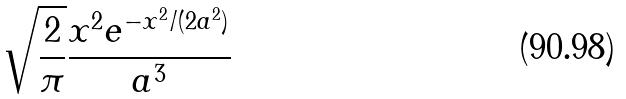Convert formula to latex. <formula><loc_0><loc_0><loc_500><loc_500>\sqrt { \frac { 2 } { \pi } } \frac { x ^ { 2 } e ^ { - x ^ { 2 } / ( 2 a ^ { 2 } ) } } { a ^ { 3 } }</formula> 